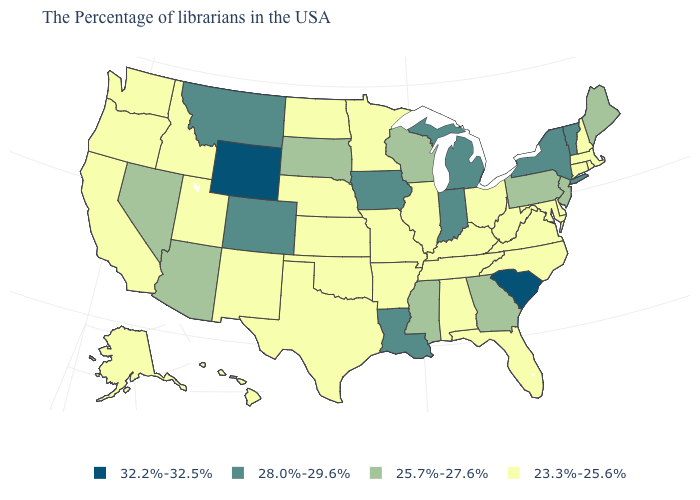Name the states that have a value in the range 25.7%-27.6%?
Give a very brief answer. Maine, New Jersey, Pennsylvania, Georgia, Wisconsin, Mississippi, South Dakota, Arizona, Nevada. What is the value of Iowa?
Write a very short answer. 28.0%-29.6%. What is the value of Georgia?
Answer briefly. 25.7%-27.6%. What is the value of Maryland?
Concise answer only. 23.3%-25.6%. Is the legend a continuous bar?
Quick response, please. No. What is the lowest value in the South?
Short answer required. 23.3%-25.6%. Is the legend a continuous bar?
Quick response, please. No. Name the states that have a value in the range 25.7%-27.6%?
Answer briefly. Maine, New Jersey, Pennsylvania, Georgia, Wisconsin, Mississippi, South Dakota, Arizona, Nevada. Does Nebraska have a lower value than Texas?
Give a very brief answer. No. Does the first symbol in the legend represent the smallest category?
Be succinct. No. Does South Carolina have the highest value in the USA?
Be succinct. Yes. Is the legend a continuous bar?
Write a very short answer. No. Name the states that have a value in the range 28.0%-29.6%?
Keep it brief. Vermont, New York, Michigan, Indiana, Louisiana, Iowa, Colorado, Montana. What is the value of New Hampshire?
Concise answer only. 23.3%-25.6%. Does Nebraska have the highest value in the MidWest?
Quick response, please. No. 